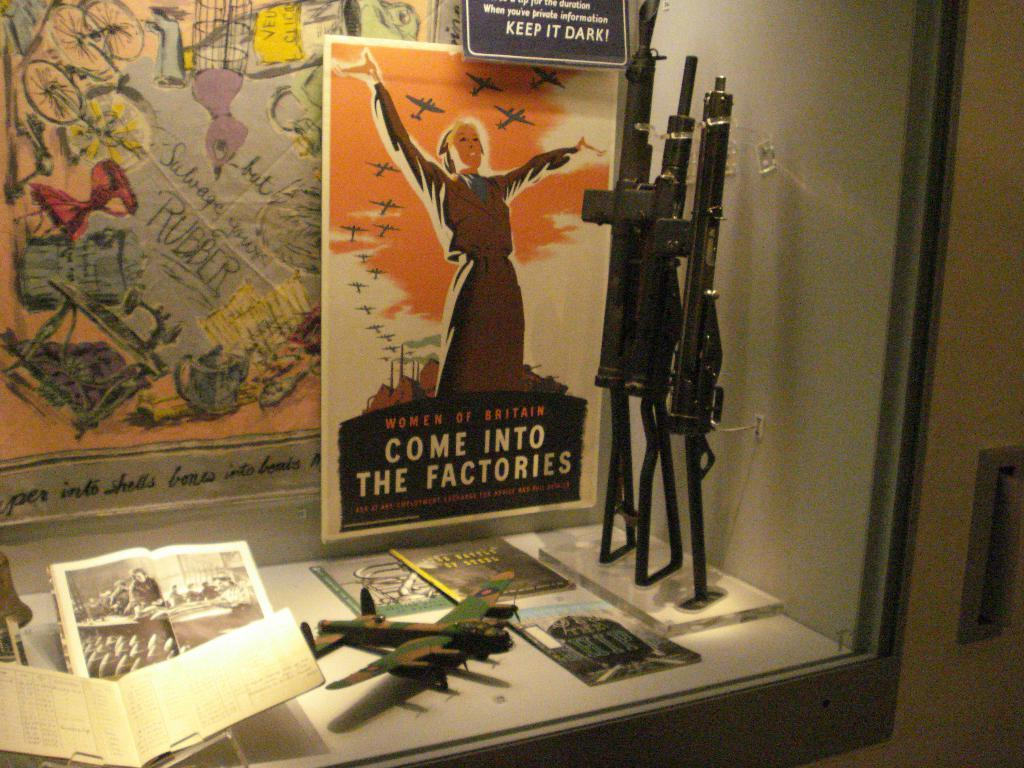<image>
Give a short and clear explanation of the subsequent image. An exhibit at a museum that says Come Into The Factories. 